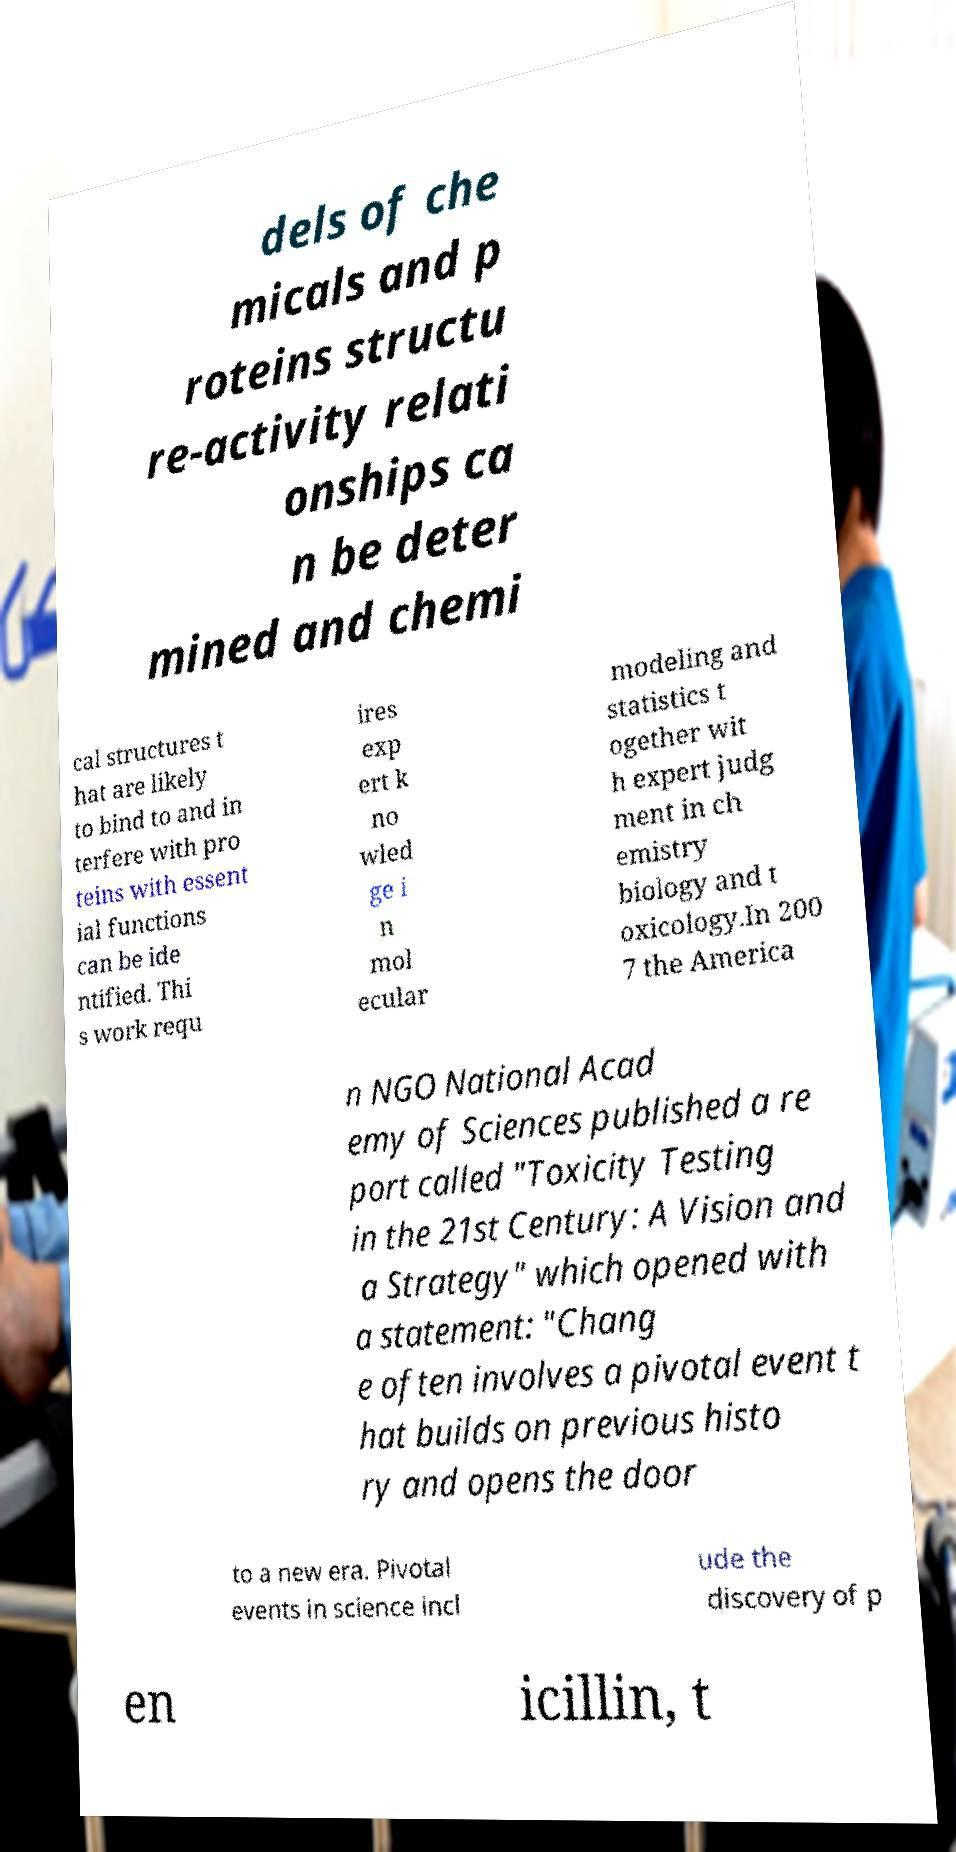I need the written content from this picture converted into text. Can you do that? dels of che micals and p roteins structu re-activity relati onships ca n be deter mined and chemi cal structures t hat are likely to bind to and in terfere with pro teins with essent ial functions can be ide ntified. Thi s work requ ires exp ert k no wled ge i n mol ecular modeling and statistics t ogether wit h expert judg ment in ch emistry biology and t oxicology.In 200 7 the America n NGO National Acad emy of Sciences published a re port called "Toxicity Testing in the 21st Century: A Vision and a Strategy" which opened with a statement: "Chang e often involves a pivotal event t hat builds on previous histo ry and opens the door to a new era. Pivotal events in science incl ude the discovery of p en icillin, t 